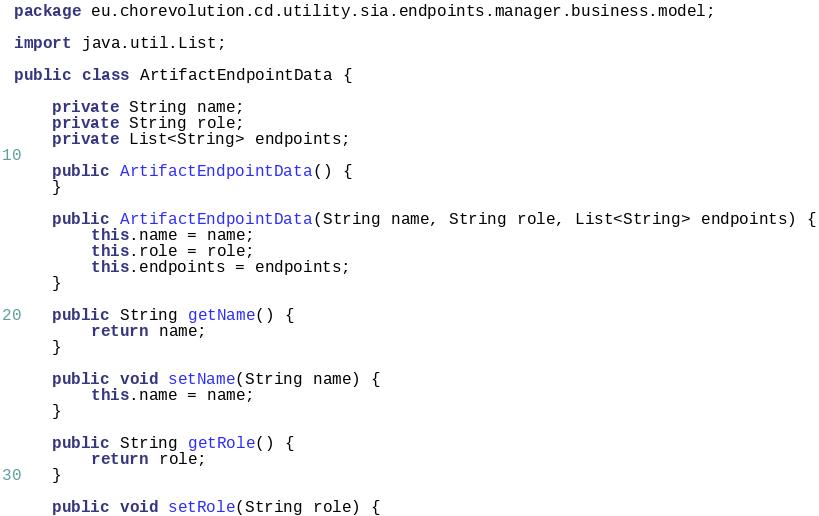<code> <loc_0><loc_0><loc_500><loc_500><_Java_>package eu.chorevolution.cd.utility.sia.endpoints.manager.business.model;

import java.util.List;

public class ArtifactEndpointData {

	private String name;
	private String role;
	private List<String> endpoints;
	
	public ArtifactEndpointData() {
	}

	public ArtifactEndpointData(String name, String role, List<String> endpoints) {
		this.name = name;
		this.role = role;
		this.endpoints = endpoints;
	}

	public String getName() {
		return name;
	}

	public void setName(String name) {
		this.name = name;
	}

	public String getRole() {
		return role;
	}

	public void setRole(String role) {</code> 